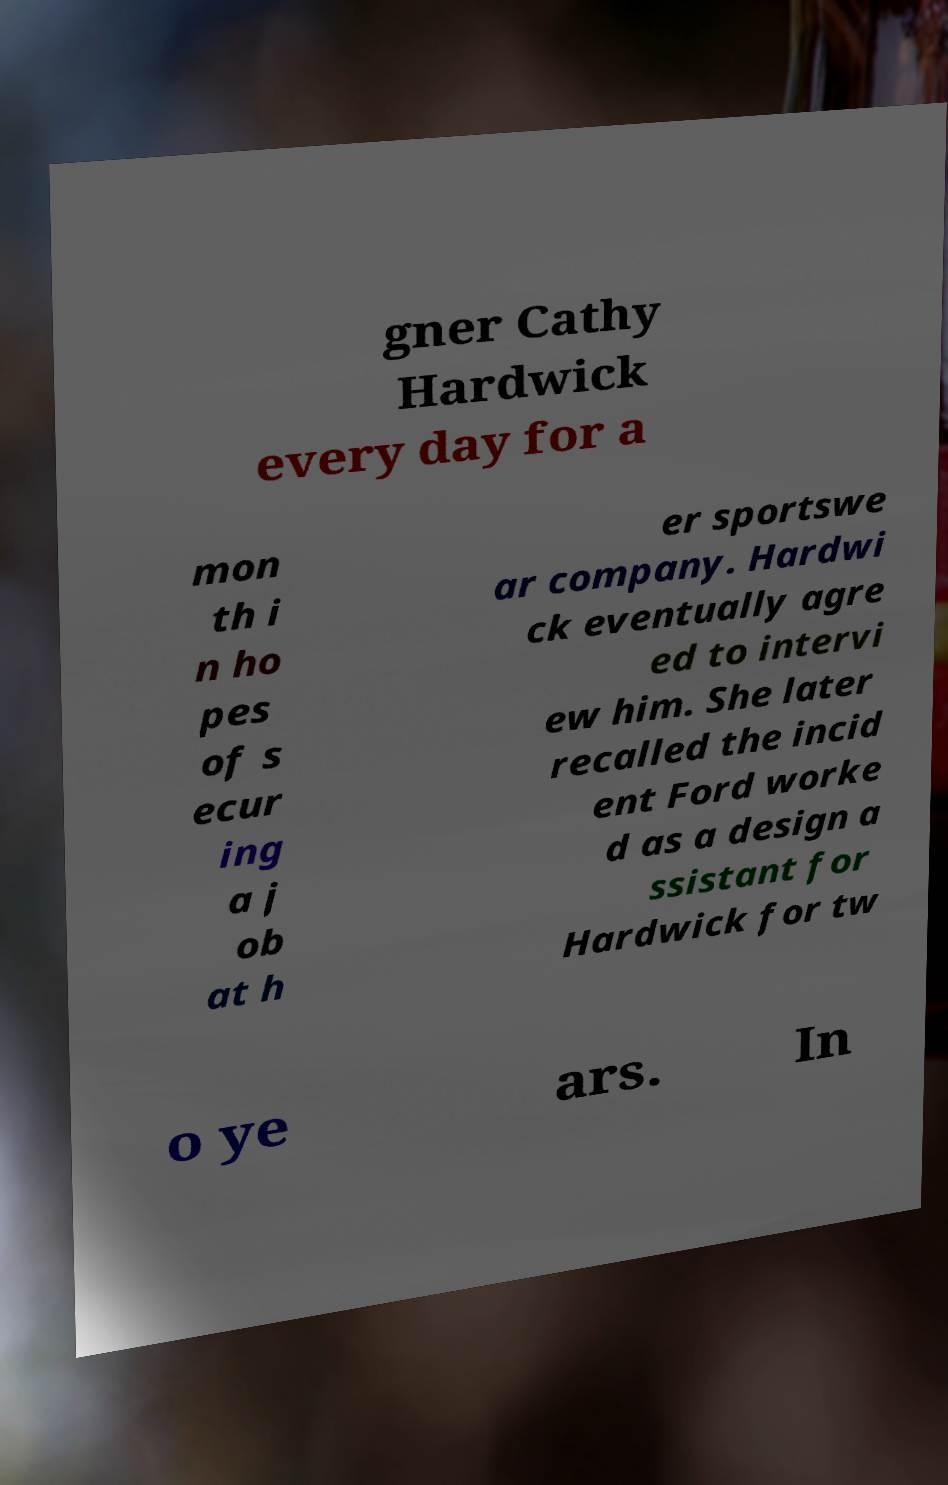Please read and relay the text visible in this image. What does it say? gner Cathy Hardwick every day for a mon th i n ho pes of s ecur ing a j ob at h er sportswe ar company. Hardwi ck eventually agre ed to intervi ew him. She later recalled the incid ent Ford worke d as a design a ssistant for Hardwick for tw o ye ars. In 